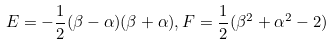<formula> <loc_0><loc_0><loc_500><loc_500>E = - \frac { 1 } { 2 } ( \beta - \alpha ) ( \beta + \alpha ) , F = \frac { 1 } { 2 } ( \beta ^ { 2 } + \alpha ^ { 2 } - 2 )</formula> 